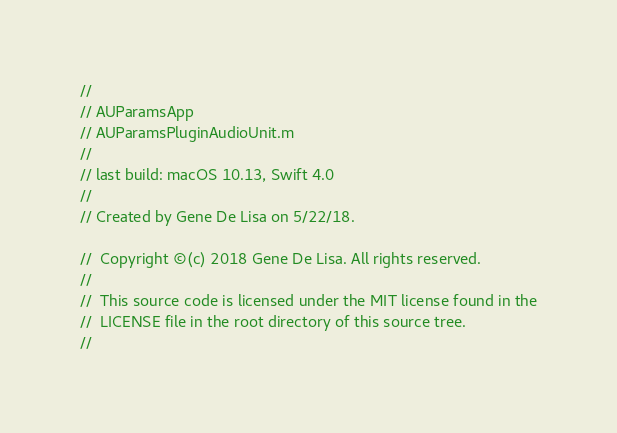Convert code to text. <code><loc_0><loc_0><loc_500><loc_500><_ObjectiveC_>//
// AUParamsApp
// AUParamsPluginAudioUnit.m
//
// last build: macOS 10.13, Swift 4.0
//
// Created by Gene De Lisa on 5/22/18.
 
//  Copyright ©(c) 2018 Gene De Lisa. All rights reserved.
//
//  This source code is licensed under the MIT license found in the
//  LICENSE file in the root directory of this source tree.
//</code> 